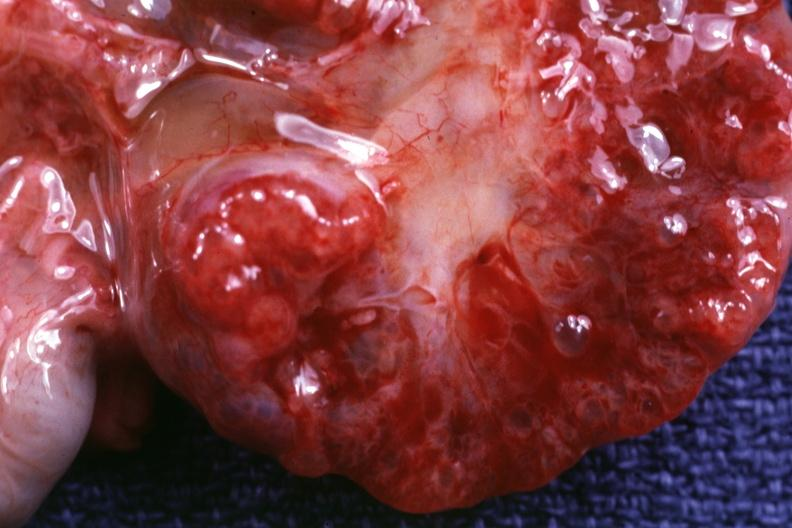what does this image show?
Answer the question using a single word or phrase. Close-up of cut surface 